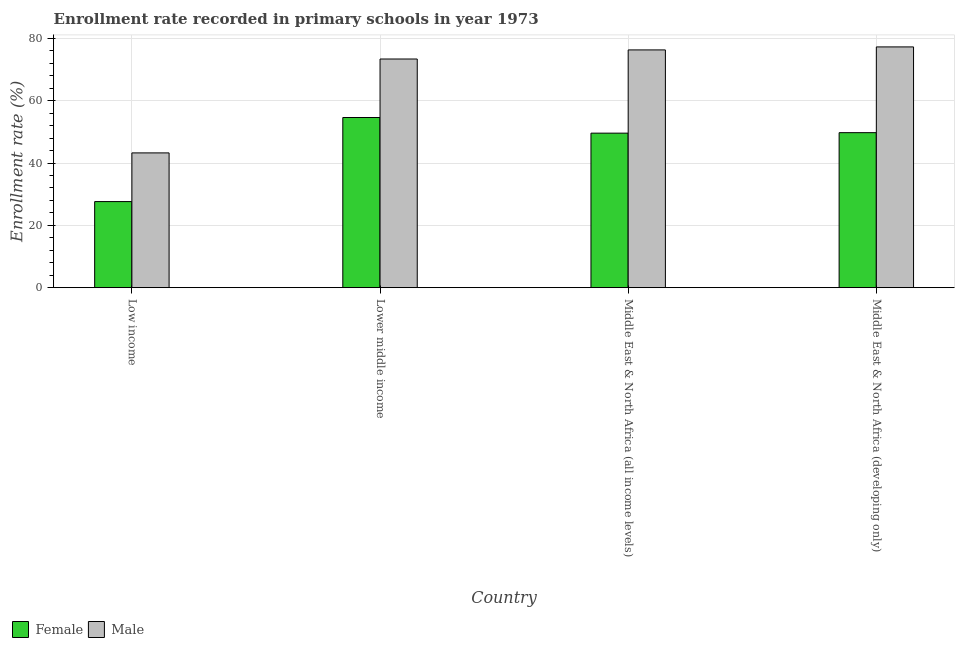How many different coloured bars are there?
Provide a short and direct response. 2. Are the number of bars per tick equal to the number of legend labels?
Your answer should be compact. Yes. Are the number of bars on each tick of the X-axis equal?
Keep it short and to the point. Yes. How many bars are there on the 2nd tick from the right?
Offer a terse response. 2. What is the label of the 3rd group of bars from the left?
Offer a very short reply. Middle East & North Africa (all income levels). In how many cases, is the number of bars for a given country not equal to the number of legend labels?
Provide a succinct answer. 0. What is the enrollment rate of female students in Low income?
Give a very brief answer. 27.63. Across all countries, what is the maximum enrollment rate of female students?
Ensure brevity in your answer.  54.62. Across all countries, what is the minimum enrollment rate of male students?
Make the answer very short. 43.26. In which country was the enrollment rate of male students maximum?
Provide a short and direct response. Middle East & North Africa (developing only). In which country was the enrollment rate of male students minimum?
Make the answer very short. Low income. What is the total enrollment rate of female students in the graph?
Ensure brevity in your answer.  181.61. What is the difference between the enrollment rate of female students in Lower middle income and that in Middle East & North Africa (developing only)?
Your answer should be very brief. 4.86. What is the difference between the enrollment rate of female students in Lower middle income and the enrollment rate of male students in Middle East & North Africa (all income levels)?
Provide a short and direct response. -21.7. What is the average enrollment rate of male students per country?
Offer a terse response. 67.57. What is the difference between the enrollment rate of male students and enrollment rate of female students in Low income?
Ensure brevity in your answer.  15.63. In how many countries, is the enrollment rate of male students greater than 36 %?
Offer a very short reply. 4. What is the ratio of the enrollment rate of female students in Low income to that in Lower middle income?
Make the answer very short. 0.51. Is the difference between the enrollment rate of male students in Low income and Lower middle income greater than the difference between the enrollment rate of female students in Low income and Lower middle income?
Offer a very short reply. No. What is the difference between the highest and the second highest enrollment rate of male students?
Provide a succinct answer. 0.96. What is the difference between the highest and the lowest enrollment rate of female students?
Provide a succinct answer. 26.99. Are all the bars in the graph horizontal?
Your answer should be very brief. No. How many countries are there in the graph?
Ensure brevity in your answer.  4. What is the difference between two consecutive major ticks on the Y-axis?
Your answer should be very brief. 20. Does the graph contain grids?
Ensure brevity in your answer.  Yes. How are the legend labels stacked?
Make the answer very short. Horizontal. What is the title of the graph?
Provide a succinct answer. Enrollment rate recorded in primary schools in year 1973. Does "Long-term debt" appear as one of the legend labels in the graph?
Make the answer very short. No. What is the label or title of the Y-axis?
Your response must be concise. Enrollment rate (%). What is the Enrollment rate (%) in Female in Low income?
Offer a very short reply. 27.63. What is the Enrollment rate (%) in Male in Low income?
Offer a terse response. 43.26. What is the Enrollment rate (%) of Female in Lower middle income?
Make the answer very short. 54.62. What is the Enrollment rate (%) in Male in Lower middle income?
Offer a terse response. 73.4. What is the Enrollment rate (%) of Female in Middle East & North Africa (all income levels)?
Ensure brevity in your answer.  49.6. What is the Enrollment rate (%) of Male in Middle East & North Africa (all income levels)?
Make the answer very short. 76.32. What is the Enrollment rate (%) of Female in Middle East & North Africa (developing only)?
Your response must be concise. 49.76. What is the Enrollment rate (%) of Male in Middle East & North Africa (developing only)?
Ensure brevity in your answer.  77.28. Across all countries, what is the maximum Enrollment rate (%) in Female?
Keep it short and to the point. 54.62. Across all countries, what is the maximum Enrollment rate (%) of Male?
Ensure brevity in your answer.  77.28. Across all countries, what is the minimum Enrollment rate (%) in Female?
Your response must be concise. 27.63. Across all countries, what is the minimum Enrollment rate (%) in Male?
Make the answer very short. 43.26. What is the total Enrollment rate (%) in Female in the graph?
Make the answer very short. 181.61. What is the total Enrollment rate (%) of Male in the graph?
Your answer should be very brief. 270.27. What is the difference between the Enrollment rate (%) in Female in Low income and that in Lower middle income?
Your response must be concise. -26.99. What is the difference between the Enrollment rate (%) in Male in Low income and that in Lower middle income?
Your response must be concise. -30.14. What is the difference between the Enrollment rate (%) of Female in Low income and that in Middle East & North Africa (all income levels)?
Your answer should be compact. -21.97. What is the difference between the Enrollment rate (%) of Male in Low income and that in Middle East & North Africa (all income levels)?
Keep it short and to the point. -33.06. What is the difference between the Enrollment rate (%) in Female in Low income and that in Middle East & North Africa (developing only)?
Your answer should be compact. -22.13. What is the difference between the Enrollment rate (%) of Male in Low income and that in Middle East & North Africa (developing only)?
Give a very brief answer. -34.02. What is the difference between the Enrollment rate (%) of Female in Lower middle income and that in Middle East & North Africa (all income levels)?
Provide a short and direct response. 5.02. What is the difference between the Enrollment rate (%) of Male in Lower middle income and that in Middle East & North Africa (all income levels)?
Offer a very short reply. -2.92. What is the difference between the Enrollment rate (%) in Female in Lower middle income and that in Middle East & North Africa (developing only)?
Provide a short and direct response. 4.86. What is the difference between the Enrollment rate (%) of Male in Lower middle income and that in Middle East & North Africa (developing only)?
Provide a short and direct response. -3.88. What is the difference between the Enrollment rate (%) of Female in Middle East & North Africa (all income levels) and that in Middle East & North Africa (developing only)?
Give a very brief answer. -0.16. What is the difference between the Enrollment rate (%) of Male in Middle East & North Africa (all income levels) and that in Middle East & North Africa (developing only)?
Your response must be concise. -0.96. What is the difference between the Enrollment rate (%) of Female in Low income and the Enrollment rate (%) of Male in Lower middle income?
Your answer should be very brief. -45.77. What is the difference between the Enrollment rate (%) of Female in Low income and the Enrollment rate (%) of Male in Middle East & North Africa (all income levels)?
Provide a short and direct response. -48.69. What is the difference between the Enrollment rate (%) of Female in Low income and the Enrollment rate (%) of Male in Middle East & North Africa (developing only)?
Your answer should be very brief. -49.65. What is the difference between the Enrollment rate (%) in Female in Lower middle income and the Enrollment rate (%) in Male in Middle East & North Africa (all income levels)?
Offer a very short reply. -21.7. What is the difference between the Enrollment rate (%) of Female in Lower middle income and the Enrollment rate (%) of Male in Middle East & North Africa (developing only)?
Keep it short and to the point. -22.66. What is the difference between the Enrollment rate (%) of Female in Middle East & North Africa (all income levels) and the Enrollment rate (%) of Male in Middle East & North Africa (developing only)?
Ensure brevity in your answer.  -27.68. What is the average Enrollment rate (%) of Female per country?
Your answer should be compact. 45.4. What is the average Enrollment rate (%) of Male per country?
Offer a terse response. 67.57. What is the difference between the Enrollment rate (%) in Female and Enrollment rate (%) in Male in Low income?
Make the answer very short. -15.63. What is the difference between the Enrollment rate (%) of Female and Enrollment rate (%) of Male in Lower middle income?
Give a very brief answer. -18.78. What is the difference between the Enrollment rate (%) of Female and Enrollment rate (%) of Male in Middle East & North Africa (all income levels)?
Offer a terse response. -26.72. What is the difference between the Enrollment rate (%) in Female and Enrollment rate (%) in Male in Middle East & North Africa (developing only)?
Ensure brevity in your answer.  -27.53. What is the ratio of the Enrollment rate (%) of Female in Low income to that in Lower middle income?
Offer a very short reply. 0.51. What is the ratio of the Enrollment rate (%) in Male in Low income to that in Lower middle income?
Offer a terse response. 0.59. What is the ratio of the Enrollment rate (%) of Female in Low income to that in Middle East & North Africa (all income levels)?
Provide a short and direct response. 0.56. What is the ratio of the Enrollment rate (%) in Male in Low income to that in Middle East & North Africa (all income levels)?
Keep it short and to the point. 0.57. What is the ratio of the Enrollment rate (%) in Female in Low income to that in Middle East & North Africa (developing only)?
Ensure brevity in your answer.  0.56. What is the ratio of the Enrollment rate (%) in Male in Low income to that in Middle East & North Africa (developing only)?
Offer a terse response. 0.56. What is the ratio of the Enrollment rate (%) of Female in Lower middle income to that in Middle East & North Africa (all income levels)?
Provide a short and direct response. 1.1. What is the ratio of the Enrollment rate (%) of Male in Lower middle income to that in Middle East & North Africa (all income levels)?
Your answer should be compact. 0.96. What is the ratio of the Enrollment rate (%) of Female in Lower middle income to that in Middle East & North Africa (developing only)?
Make the answer very short. 1.1. What is the ratio of the Enrollment rate (%) of Male in Lower middle income to that in Middle East & North Africa (developing only)?
Your answer should be very brief. 0.95. What is the ratio of the Enrollment rate (%) of Male in Middle East & North Africa (all income levels) to that in Middle East & North Africa (developing only)?
Your answer should be compact. 0.99. What is the difference between the highest and the second highest Enrollment rate (%) of Female?
Your response must be concise. 4.86. What is the difference between the highest and the second highest Enrollment rate (%) of Male?
Provide a succinct answer. 0.96. What is the difference between the highest and the lowest Enrollment rate (%) of Female?
Offer a terse response. 26.99. What is the difference between the highest and the lowest Enrollment rate (%) in Male?
Offer a terse response. 34.02. 